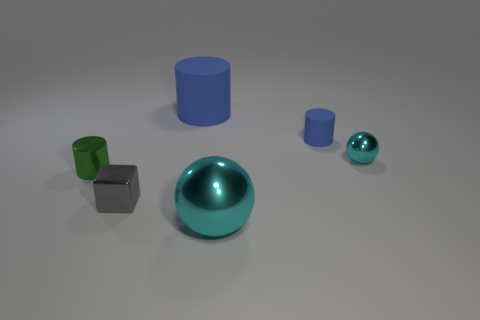How many other objects are the same shape as the green metal thing?
Give a very brief answer. 2. What shape is the blue rubber object that is to the right of the large thing behind the small metallic object that is behind the green cylinder?
Offer a very short reply. Cylinder. Does the green metallic object have the same size as the cyan shiny ball that is behind the tiny metal cylinder?
Your answer should be very brief. Yes. Are there any yellow matte spheres that have the same size as the gray thing?
Keep it short and to the point. No. What number of other objects are the same material as the large cylinder?
Provide a succinct answer. 1. What color is the cylinder that is both in front of the large blue rubber cylinder and on the right side of the small gray metal block?
Give a very brief answer. Blue. Does the ball that is behind the tiny gray thing have the same material as the ball left of the tiny blue rubber cylinder?
Your answer should be very brief. Yes. There is a cyan metal thing that is behind the green thing; is its size the same as the small green shiny cylinder?
Ensure brevity in your answer.  Yes. Does the big metallic thing have the same color as the small metallic thing on the right side of the large blue matte cylinder?
Provide a succinct answer. Yes. What is the shape of the matte object that is the same color as the big cylinder?
Provide a short and direct response. Cylinder. 